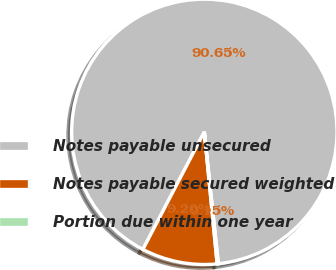Convert chart to OTSL. <chart><loc_0><loc_0><loc_500><loc_500><pie_chart><fcel>Notes payable unsecured<fcel>Notes payable secured weighted<fcel>Portion due within one year<nl><fcel>90.65%<fcel>9.2%<fcel>0.15%<nl></chart> 